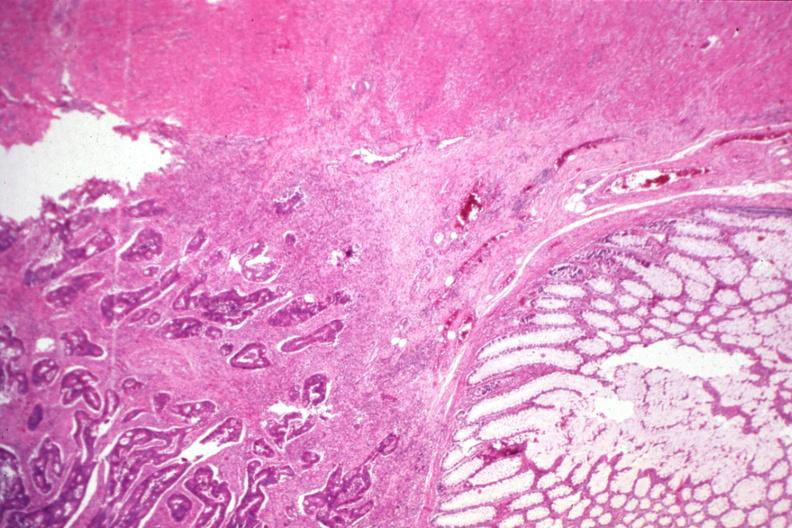s gastrointestinal present?
Answer the question using a single word or phrase. Yes 